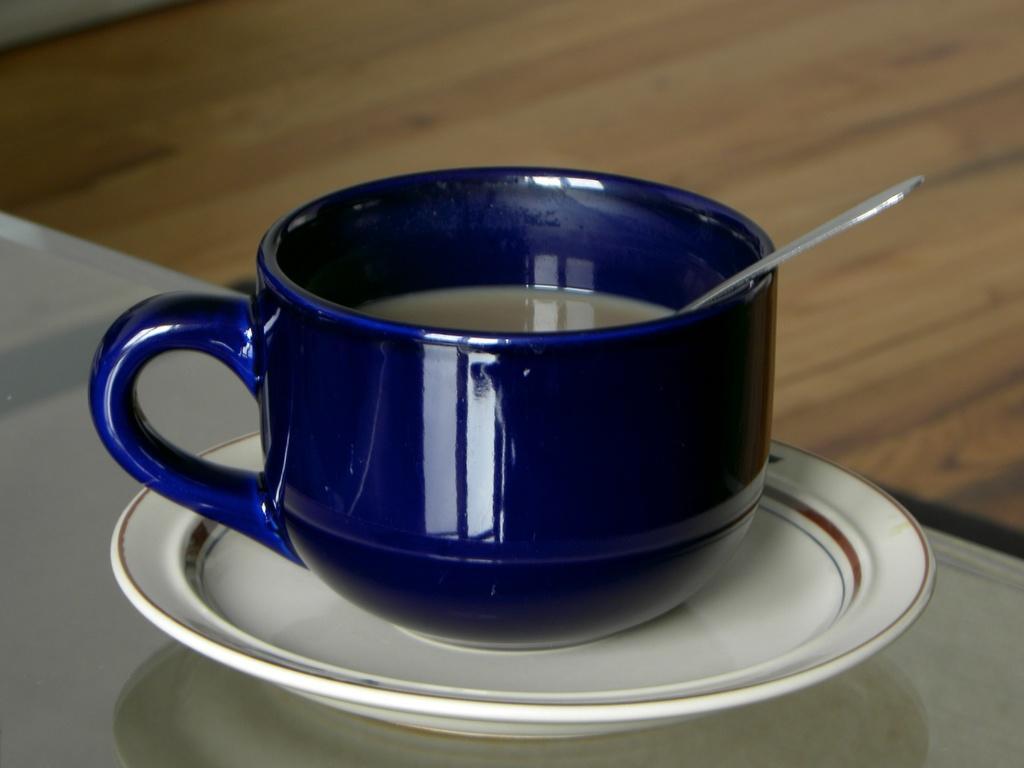Describe this image in one or two sentences. In this picture I can see the white color surface in front, on which there is a saucer and on the saucer I see a cup which is of blue color. In the cup I see the liquid and a spoon. In the background I see the brown color surface. 